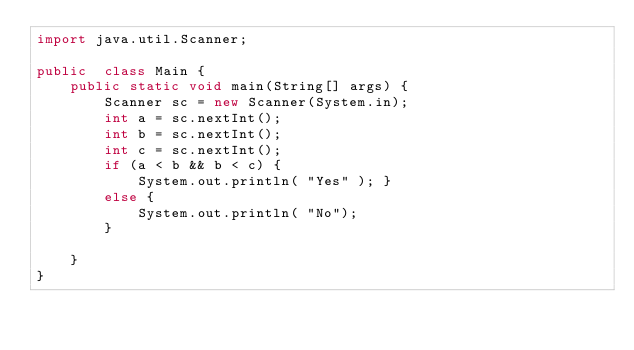<code> <loc_0><loc_0><loc_500><loc_500><_Java_>import java.util.Scanner;

public  class Main {
    public static void main(String[] args) {
        Scanner sc = new Scanner(System.in);
        int a = sc.nextInt();
        int b = sc.nextInt();
        int c = sc.nextInt();
        if (a < b && b < c) {
            System.out.println( "Yes" ); }
        else {
            System.out.println( "No");
        }

    }
}
</code> 